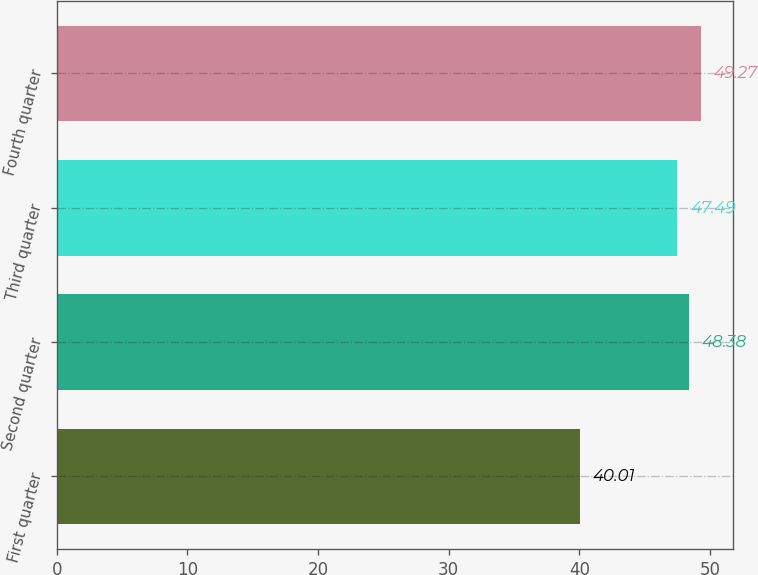Convert chart. <chart><loc_0><loc_0><loc_500><loc_500><bar_chart><fcel>First quarter<fcel>Second quarter<fcel>Third quarter<fcel>Fourth quarter<nl><fcel>40.01<fcel>48.38<fcel>47.49<fcel>49.27<nl></chart> 